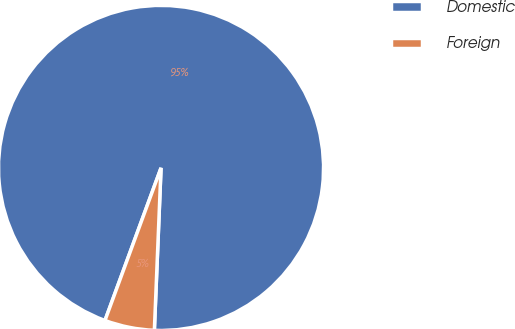<chart> <loc_0><loc_0><loc_500><loc_500><pie_chart><fcel>Domestic<fcel>Foreign<nl><fcel>95.05%<fcel>4.95%<nl></chart> 